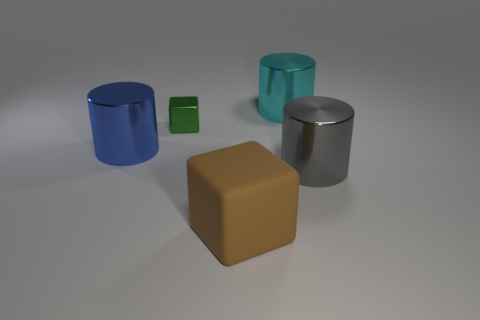Add 1 big cyan metal cylinders. How many objects exist? 6 Subtract all cylinders. How many objects are left? 2 Subtract 0 yellow cylinders. How many objects are left? 5 Subtract all tiny green metallic objects. Subtract all big metallic objects. How many objects are left? 1 Add 2 shiny things. How many shiny things are left? 6 Add 4 tiny red rubber balls. How many tiny red rubber balls exist? 4 